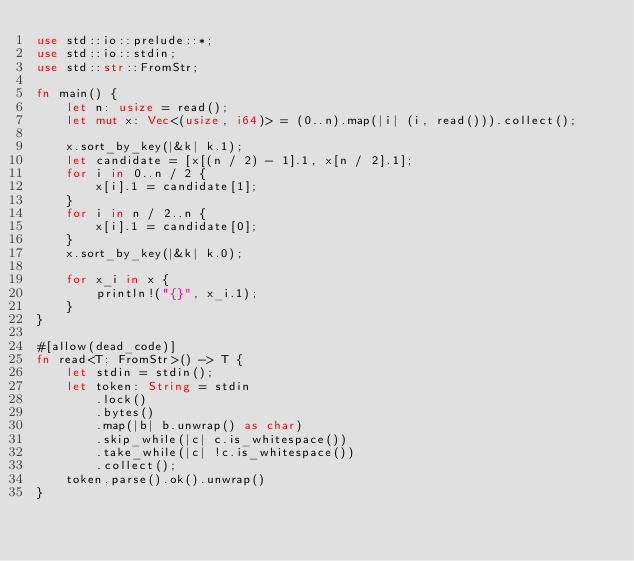<code> <loc_0><loc_0><loc_500><loc_500><_Rust_>use std::io::prelude::*;
use std::io::stdin;
use std::str::FromStr;

fn main() {
    let n: usize = read();
    let mut x: Vec<(usize, i64)> = (0..n).map(|i| (i, read())).collect();

    x.sort_by_key(|&k| k.1);
    let candidate = [x[(n / 2) - 1].1, x[n / 2].1];
    for i in 0..n / 2 {
        x[i].1 = candidate[1];
    }
    for i in n / 2..n {
        x[i].1 = candidate[0];
    }
    x.sort_by_key(|&k| k.0);

    for x_i in x {
        println!("{}", x_i.1);
    }
}

#[allow(dead_code)]
fn read<T: FromStr>() -> T {
    let stdin = stdin();
    let token: String = stdin
        .lock()
        .bytes()
        .map(|b| b.unwrap() as char)
        .skip_while(|c| c.is_whitespace())
        .take_while(|c| !c.is_whitespace())
        .collect();
    token.parse().ok().unwrap()
}
</code> 